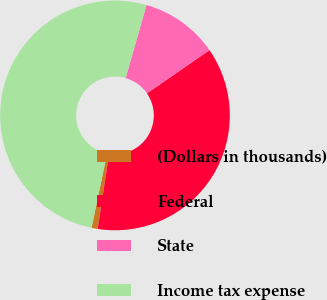<chart> <loc_0><loc_0><loc_500><loc_500><pie_chart><fcel>(Dollars in thousands)<fcel>Federal<fcel>State<fcel>Income tax expense<nl><fcel>0.86%<fcel>37.03%<fcel>10.95%<fcel>51.15%<nl></chart> 